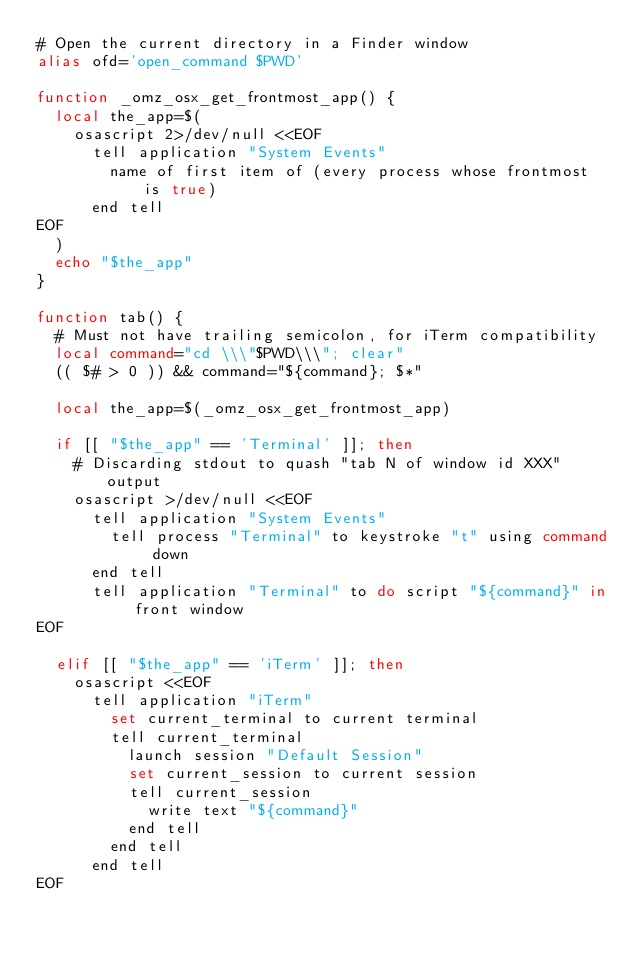Convert code to text. <code><loc_0><loc_0><loc_500><loc_500><_Bash_># Open the current directory in a Finder window
alias ofd='open_command $PWD'

function _omz_osx_get_frontmost_app() {
  local the_app=$(
    osascript 2>/dev/null <<EOF
      tell application "System Events"
        name of first item of (every process whose frontmost is true)
      end tell
EOF
  )
  echo "$the_app"
}

function tab() {
  # Must not have trailing semicolon, for iTerm compatibility
  local command="cd \\\"$PWD\\\"; clear"
  (( $# > 0 )) && command="${command}; $*"

  local the_app=$(_omz_osx_get_frontmost_app)

  if [[ "$the_app" == 'Terminal' ]]; then
    # Discarding stdout to quash "tab N of window id XXX" output
    osascript >/dev/null <<EOF
      tell application "System Events"
        tell process "Terminal" to keystroke "t" using command down
      end tell
      tell application "Terminal" to do script "${command}" in front window
EOF

  elif [[ "$the_app" == 'iTerm' ]]; then
    osascript <<EOF
      tell application "iTerm"
        set current_terminal to current terminal
        tell current_terminal
          launch session "Default Session"
          set current_session to current session
          tell current_session
            write text "${command}"
          end tell
        end tell
      end tell
EOF
</code> 